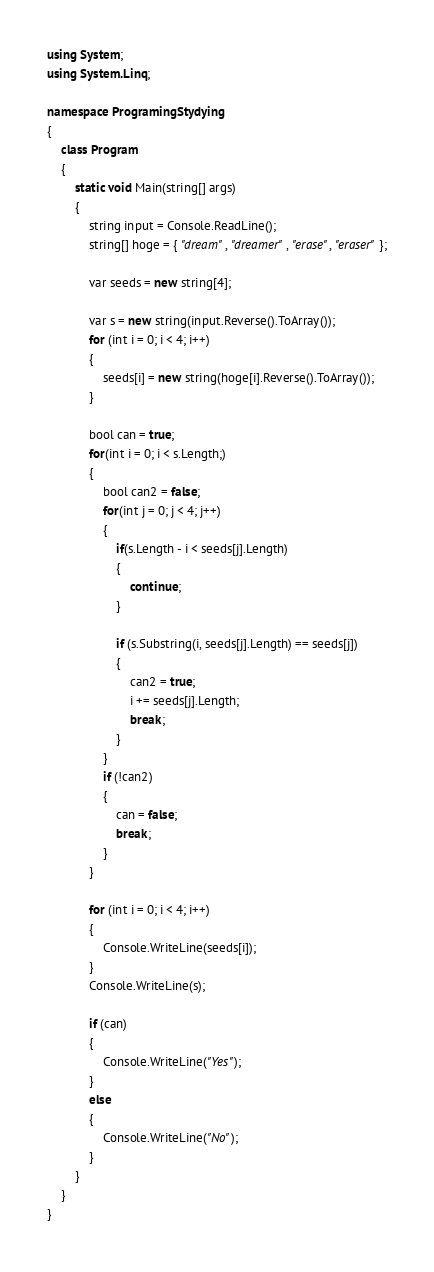<code> <loc_0><loc_0><loc_500><loc_500><_C#_>using System;
using System.Linq;

namespace ProgramingStydying
{
    class Program
    {
        static void Main(string[] args)
        {
            string input = Console.ReadLine();
            string[] hoge = { "dream", "dreamer", "erase", "eraser" };

            var seeds = new string[4];

            var s = new string(input.Reverse().ToArray());
            for (int i = 0; i < 4; i++)
            {
                seeds[i] = new string(hoge[i].Reverse().ToArray());
            }

            bool can = true;
            for(int i = 0; i < s.Length;)
            {
                bool can2 = false;
                for(int j = 0; j < 4; j++)
                {
                    if(s.Length - i < seeds[j].Length)
                    {
                        continue;
                    }

                    if (s.Substring(i, seeds[j].Length) == seeds[j])
                    {
                        can2 = true;
                        i += seeds[j].Length;
                        break;
                    }
                }
                if (!can2)
                {
                    can = false;
                    break;
                }
            }

            for (int i = 0; i < 4; i++)
            {
                Console.WriteLine(seeds[i]);
            }
            Console.WriteLine(s);

            if (can)
            {
                Console.WriteLine("Yes");
            }
            else
            {
                Console.WriteLine("No");
            }
        }
    }
}</code> 